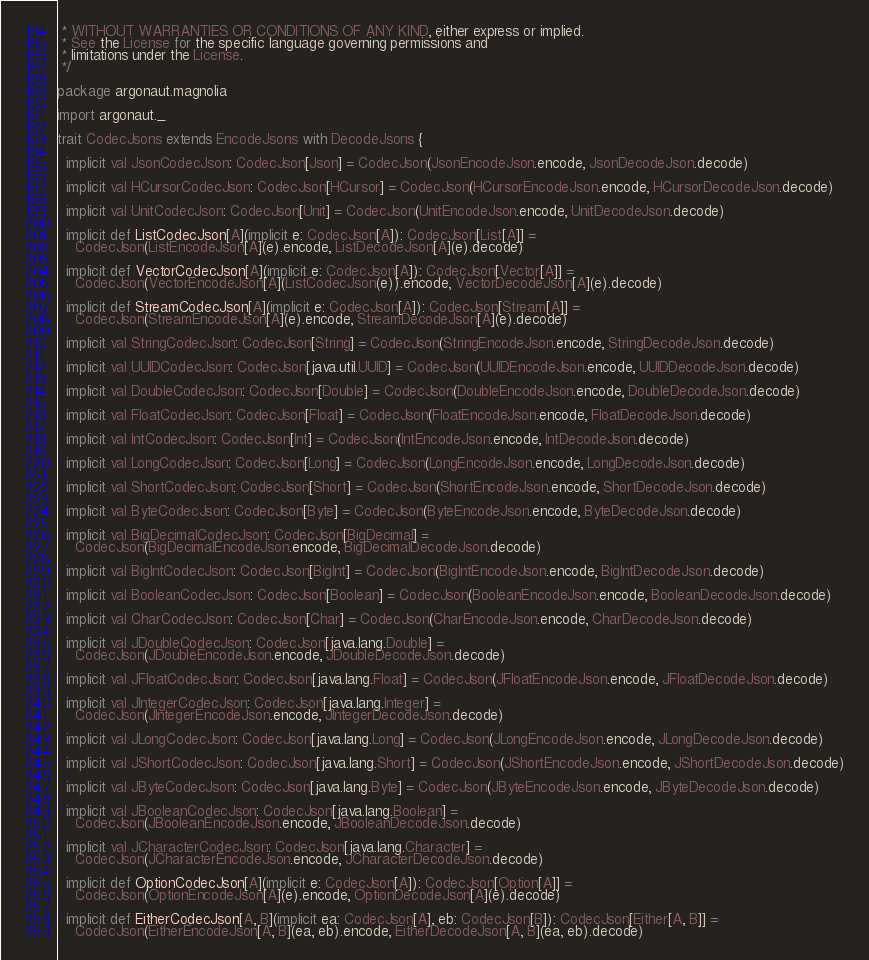Convert code to text. <code><loc_0><loc_0><loc_500><loc_500><_Scala_> * WITHOUT WARRANTIES OR CONDITIONS OF ANY KIND, either express or implied.
 * See the License for the specific language governing permissions and
 * limitations under the License.
 */

package argonaut.magnolia

import argonaut._

trait CodecJsons extends EncodeJsons with DecodeJsons {

  implicit val JsonCodecJson: CodecJson[Json] = CodecJson(JsonEncodeJson.encode, JsonDecodeJson.decode)

  implicit val HCursorCodecJson: CodecJson[HCursor] = CodecJson(HCursorEncodeJson.encode, HCursorDecodeJson.decode)

  implicit val UnitCodecJson: CodecJson[Unit] = CodecJson(UnitEncodeJson.encode, UnitDecodeJson.decode)

  implicit def ListCodecJson[A](implicit e: CodecJson[A]): CodecJson[List[A]] =
    CodecJson(ListEncodeJson[A](e).encode, ListDecodeJson[A](e).decode)

  implicit def VectorCodecJson[A](implicit e: CodecJson[A]): CodecJson[Vector[A]] =
    CodecJson(VectorEncodeJson[A](ListCodecJson(e)).encode, VectorDecodeJson[A](e).decode)

  implicit def StreamCodecJson[A](implicit e: CodecJson[A]): CodecJson[Stream[A]] =
    CodecJson(StreamEncodeJson[A](e).encode, StreamDecodeJson[A](e).decode)

  implicit val StringCodecJson: CodecJson[String] = CodecJson(StringEncodeJson.encode, StringDecodeJson.decode)

  implicit val UUIDCodecJson: CodecJson[java.util.UUID] = CodecJson(UUIDEncodeJson.encode, UUIDDecodeJson.decode)

  implicit val DoubleCodecJson: CodecJson[Double] = CodecJson(DoubleEncodeJson.encode, DoubleDecodeJson.decode)

  implicit val FloatCodecJson: CodecJson[Float] = CodecJson(FloatEncodeJson.encode, FloatDecodeJson.decode)

  implicit val IntCodecJson: CodecJson[Int] = CodecJson(IntEncodeJson.encode, IntDecodeJson.decode)

  implicit val LongCodecJson: CodecJson[Long] = CodecJson(LongEncodeJson.encode, LongDecodeJson.decode)

  implicit val ShortCodecJson: CodecJson[Short] = CodecJson(ShortEncodeJson.encode, ShortDecodeJson.decode)

  implicit val ByteCodecJson: CodecJson[Byte] = CodecJson(ByteEncodeJson.encode, ByteDecodeJson.decode)

  implicit val BigDecimalCodecJson: CodecJson[BigDecimal] =
    CodecJson(BigDecimalEncodeJson.encode, BigDecimalDecodeJson.decode)

  implicit val BigIntCodecJson: CodecJson[BigInt] = CodecJson(BigIntEncodeJson.encode, BigIntDecodeJson.decode)

  implicit val BooleanCodecJson: CodecJson[Boolean] = CodecJson(BooleanEncodeJson.encode, BooleanDecodeJson.decode)

  implicit val CharCodecJson: CodecJson[Char] = CodecJson(CharEncodeJson.encode, CharDecodeJson.decode)

  implicit val JDoubleCodecJson: CodecJson[java.lang.Double] =
    CodecJson(JDoubleEncodeJson.encode, JDoubleDecodeJson.decode)

  implicit val JFloatCodecJson: CodecJson[java.lang.Float] = CodecJson(JFloatEncodeJson.encode, JFloatDecodeJson.decode)

  implicit val JIntegerCodecJson: CodecJson[java.lang.Integer] =
    CodecJson(JIntegerEncodeJson.encode, JIntegerDecodeJson.decode)

  implicit val JLongCodecJson: CodecJson[java.lang.Long] = CodecJson(JLongEncodeJson.encode, JLongDecodeJson.decode)

  implicit val JShortCodecJson: CodecJson[java.lang.Short] = CodecJson(JShortEncodeJson.encode, JShortDecodeJson.decode)

  implicit val JByteCodecJson: CodecJson[java.lang.Byte] = CodecJson(JByteEncodeJson.encode, JByteDecodeJson.decode)

  implicit val JBooleanCodecJson: CodecJson[java.lang.Boolean] =
    CodecJson(JBooleanEncodeJson.encode, JBooleanDecodeJson.decode)

  implicit val JCharacterCodecJson: CodecJson[java.lang.Character] =
    CodecJson(JCharacterEncodeJson.encode, JCharacterDecodeJson.decode)

  implicit def OptionCodecJson[A](implicit e: CodecJson[A]): CodecJson[Option[A]] =
    CodecJson(OptionEncodeJson[A](e).encode, OptionDecodeJson[A](e).decode)

  implicit def EitherCodecJson[A, B](implicit ea: CodecJson[A], eb: CodecJson[B]): CodecJson[Either[A, B]] =
    CodecJson(EitherEncodeJson[A, B](ea, eb).encode, EitherDecodeJson[A, B](ea, eb).decode)
</code> 